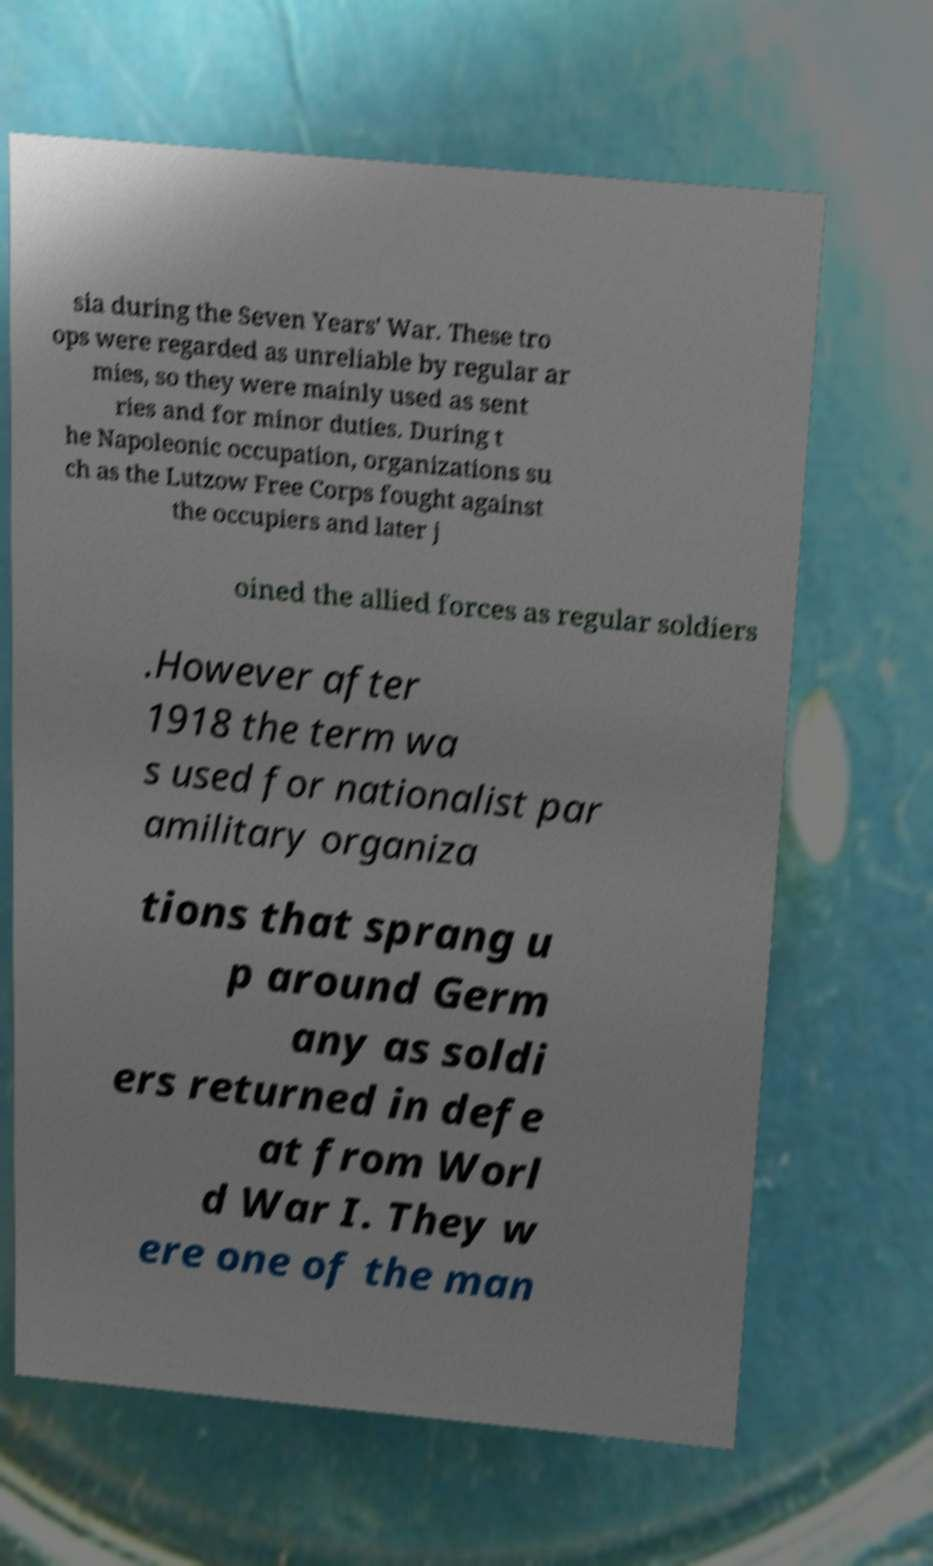I need the written content from this picture converted into text. Can you do that? sia during the Seven Years' War. These tro ops were regarded as unreliable by regular ar mies, so they were mainly used as sent ries and for minor duties. During t he Napoleonic occupation, organizations su ch as the Lutzow Free Corps fought against the occupiers and later j oined the allied forces as regular soldiers .However after 1918 the term wa s used for nationalist par amilitary organiza tions that sprang u p around Germ any as soldi ers returned in defe at from Worl d War I. They w ere one of the man 